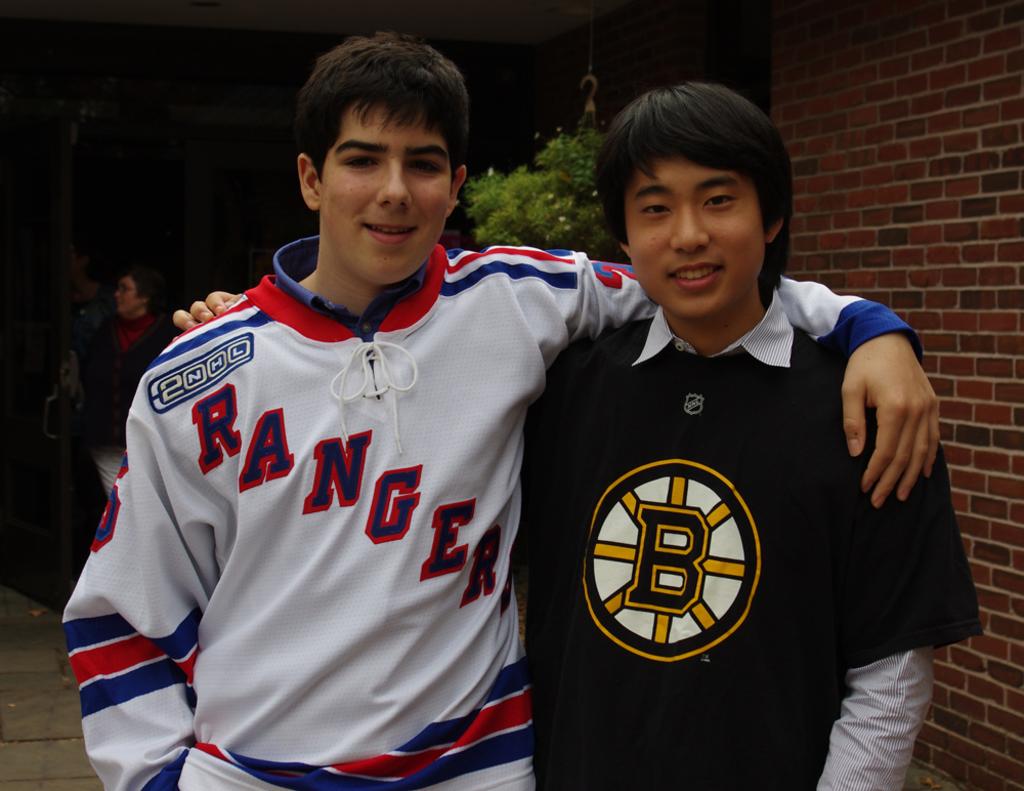What team are they representing on their jerseys?
Offer a terse response. Rangers. 